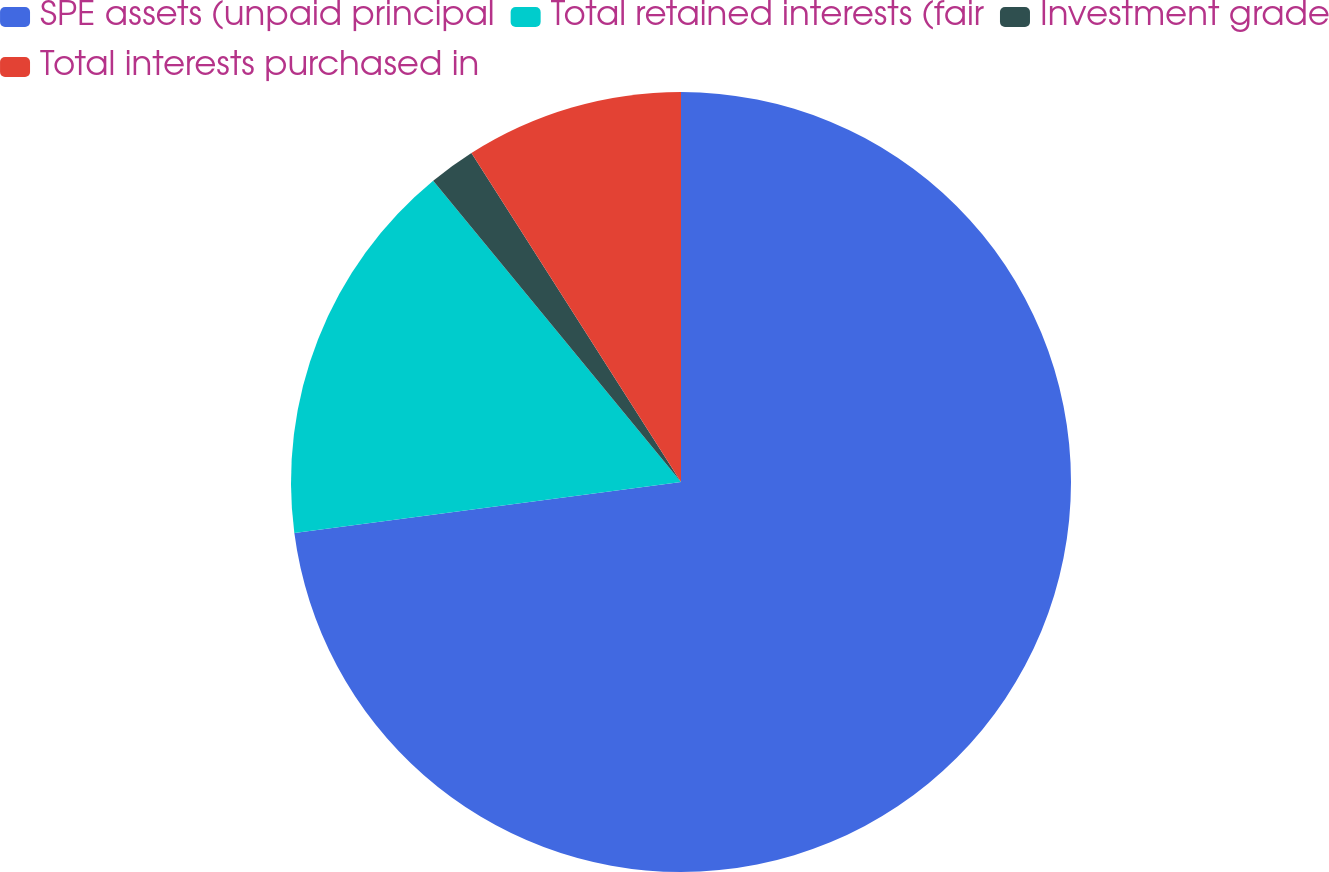<chart> <loc_0><loc_0><loc_500><loc_500><pie_chart><fcel>SPE assets (unpaid principal<fcel>Total retained interests (fair<fcel>Investment grade<fcel>Total interests purchased in<nl><fcel>72.92%<fcel>16.13%<fcel>1.93%<fcel>9.03%<nl></chart> 